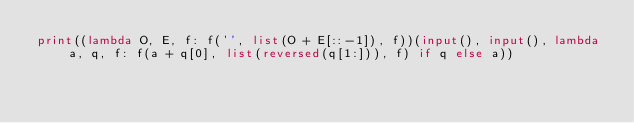Convert code to text. <code><loc_0><loc_0><loc_500><loc_500><_Python_>print((lambda O, E, f: f('', list(O + E[::-1]), f))(input(), input(), lambda a, q, f: f(a + q[0], list(reversed(q[1:])), f) if q else a))</code> 